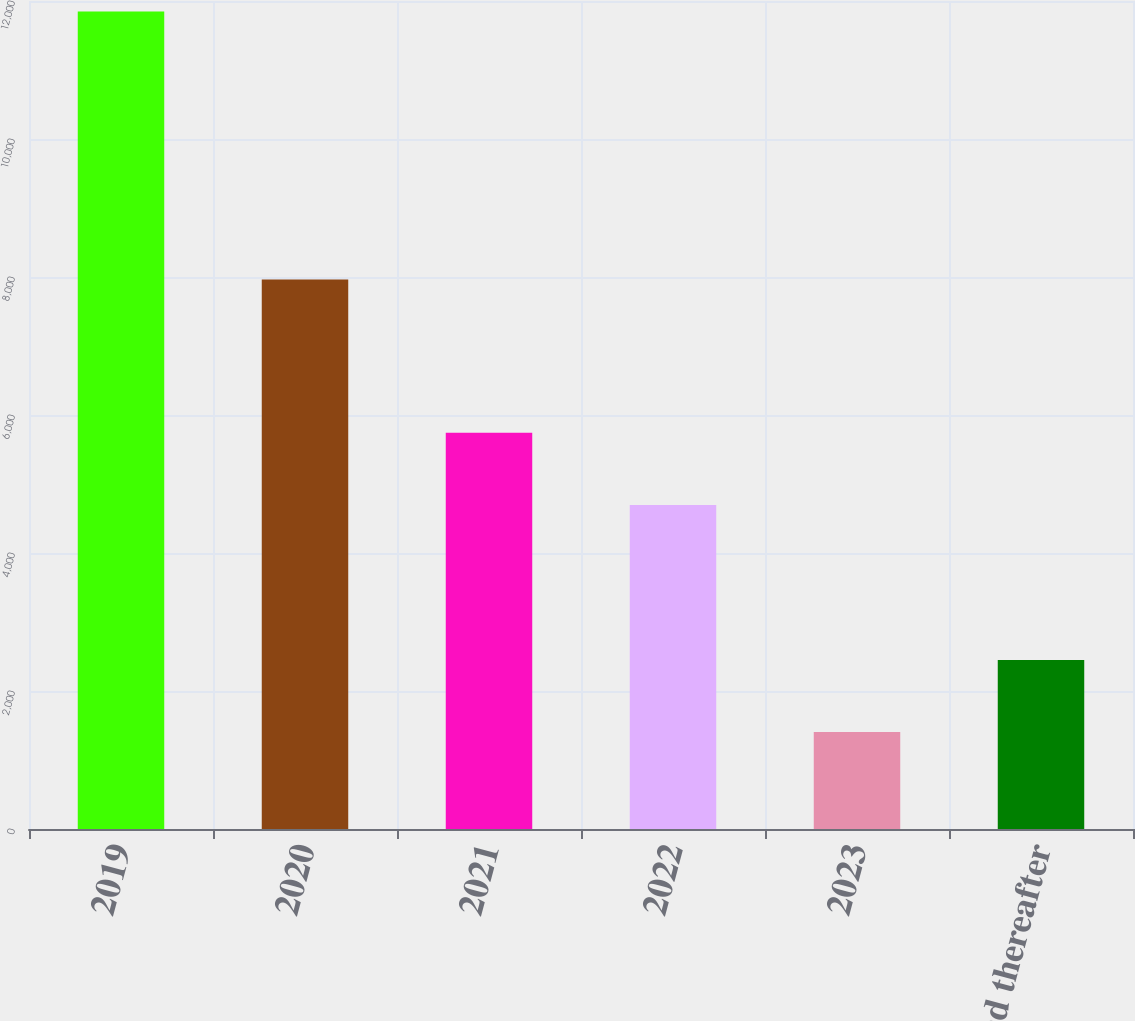Convert chart. <chart><loc_0><loc_0><loc_500><loc_500><bar_chart><fcel>2019<fcel>2020<fcel>2021<fcel>2022<fcel>2023<fcel>2024 and thereafter<nl><fcel>11847<fcel>7965<fcel>5741.3<fcel>4697<fcel>1404<fcel>2448.3<nl></chart> 